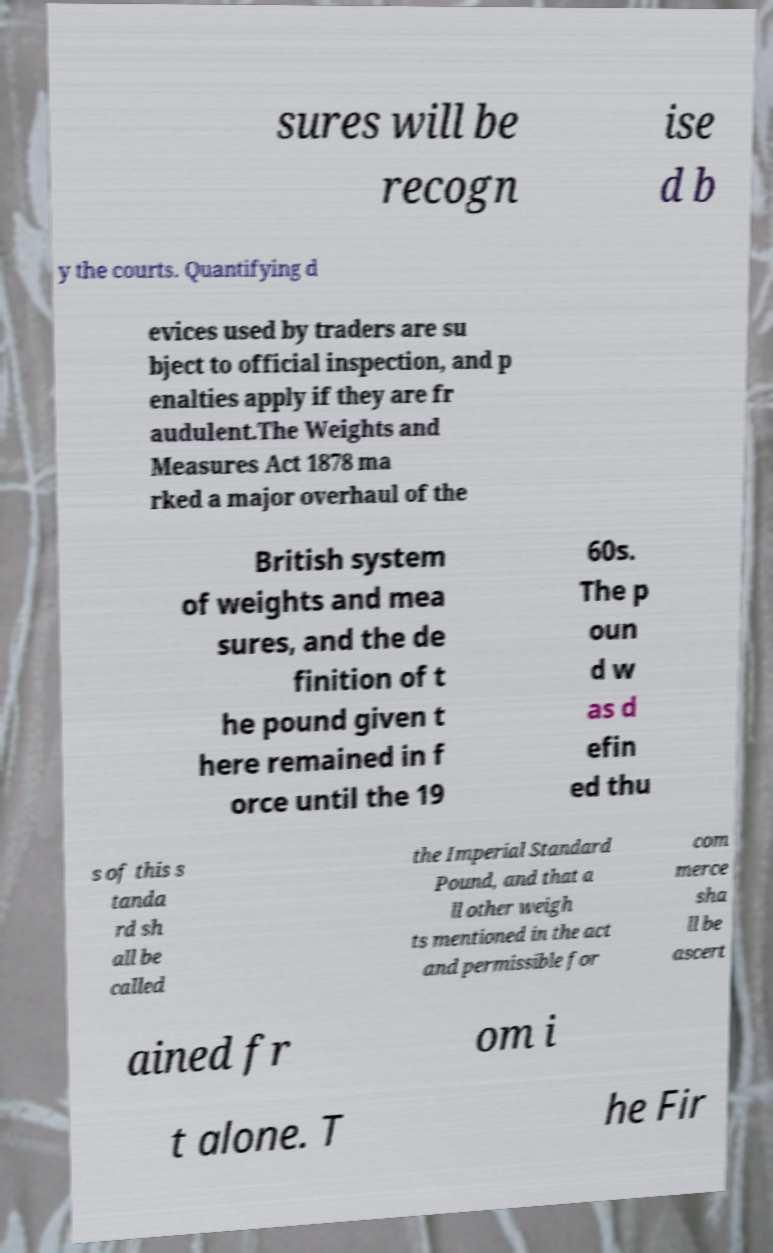Could you extract and type out the text from this image? sures will be recogn ise d b y the courts. Quantifying d evices used by traders are su bject to official inspection, and p enalties apply if they are fr audulent.The Weights and Measures Act 1878 ma rked a major overhaul of the British system of weights and mea sures, and the de finition of t he pound given t here remained in f orce until the 19 60s. The p oun d w as d efin ed thu s of this s tanda rd sh all be called the Imperial Standard Pound, and that a ll other weigh ts mentioned in the act and permissible for com merce sha ll be ascert ained fr om i t alone. T he Fir 